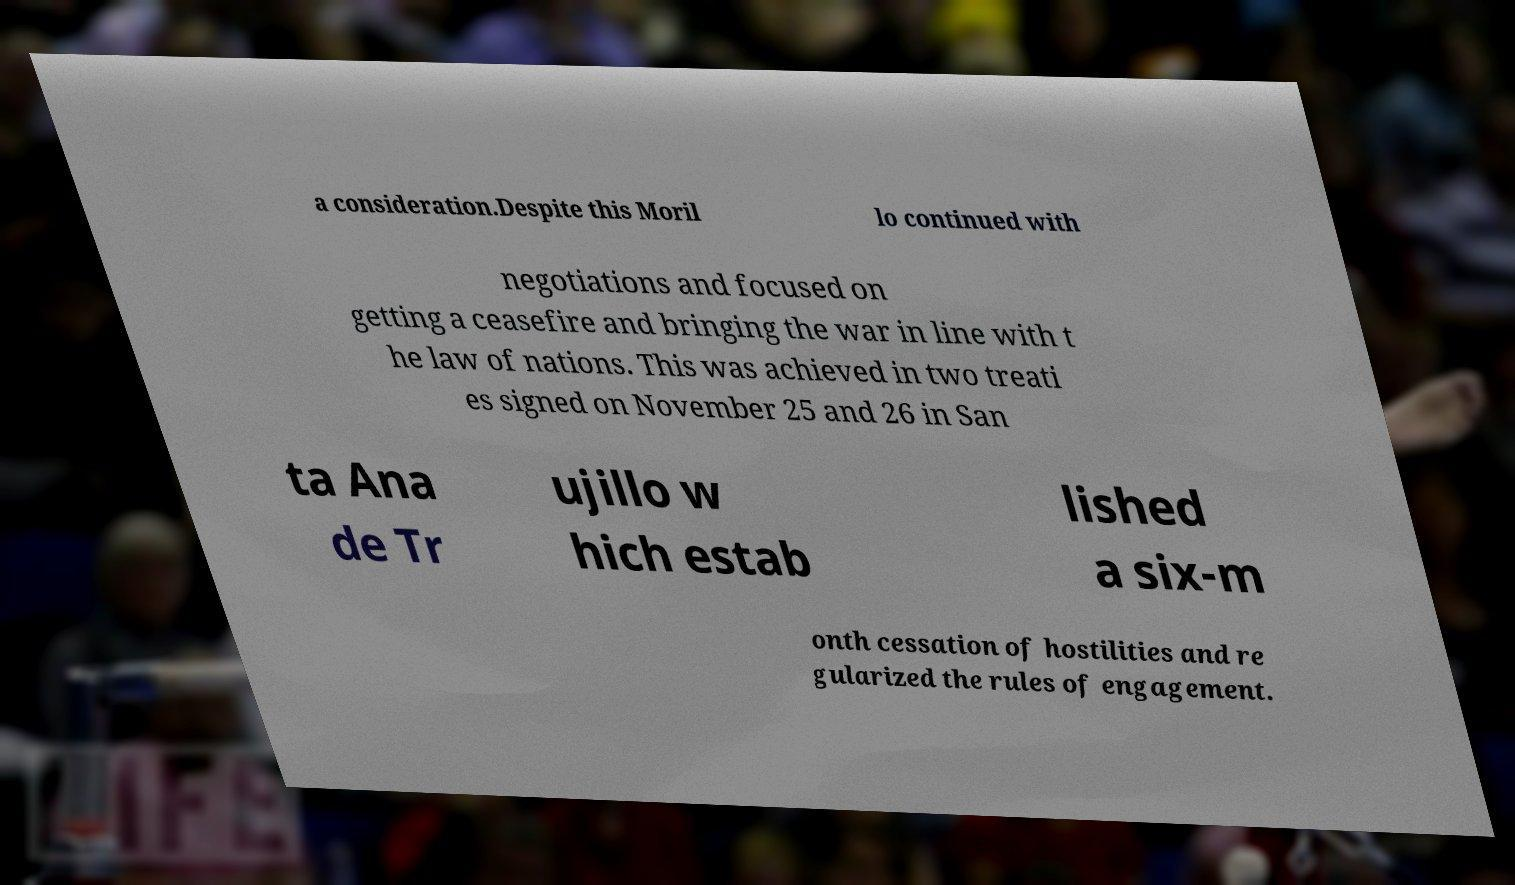Please read and relay the text visible in this image. What does it say? a consideration.Despite this Moril lo continued with negotiations and focused on getting a ceasefire and bringing the war in line with t he law of nations. This was achieved in two treati es signed on November 25 and 26 in San ta Ana de Tr ujillo w hich estab lished a six-m onth cessation of hostilities and re gularized the rules of engagement. 